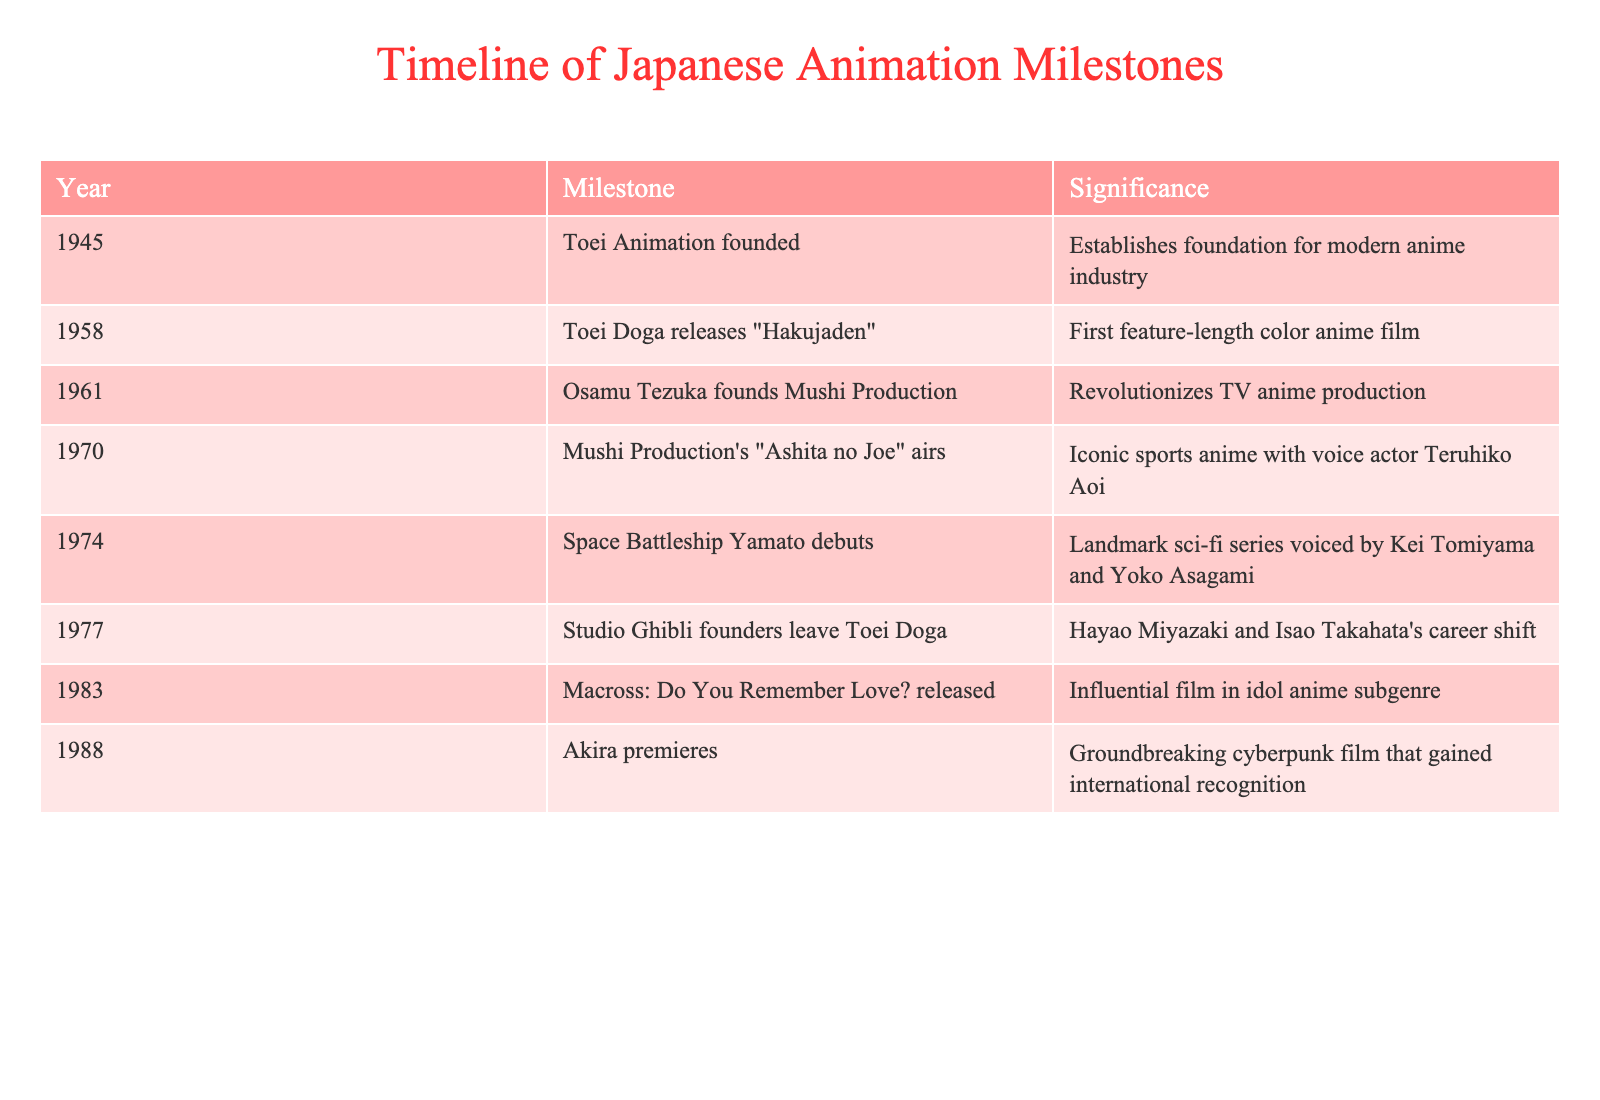What year was Toei Animation founded? The table indicates that Toei Animation was founded in the year 1945.
Answer: 1945 What milestone marked the first feature-length color anime film? According to the table, "Hakujaden" released by Toei Doga in 1958 was the first feature-length color anime film.
Answer: "Hakujaden" Which production company did Osamu Tezuka establish in 1961? The table shows that Osamu Tezuka founded Mushi Production in 1961.
Answer: Mushi Production Did "Akira" premiere before or after 1985? The table states that "Akira" premiered in 1988, which is after 1985.
Answer: After What is the significance of "Ashita no Joe"? The table notes that "Ashita no Joe" is an iconic sports anime that aired in 1970, featuring voice actor Teruhiko Aoi.
Answer: Iconic sports anime Which two notable figures left Toei Doga in 1977? The table indicates that Hayao Miyazaki and Isao Takahata are the founders who left Toei Doga in 1977.
Answer: Hayao Miyazaki and Isao Takahata How many years apart are the founding of Toei Animation and the release of "Hakujaden"? Toei Animation was founded in 1945, and "Hakujaden" was released in 1958. The difference is 1958 - 1945 = 13 years.
Answer: 13 years What significant trend can be seen between 1945 and 1988 regarding the anime industry? The table shows a progression of milestones with an increase in notable productions and innovations, suggesting a rapid growth in the anime industry from its foundation to 1988.
Answer: Rapid growth Which anime had a significant influence on the idol anime subgenre? According to the table, "Macross: Do You Remember Love?" released in 1983 had a significant influence on the idol anime subgenre.
Answer: "Macross: Do You Remember Love?" What is the first animated film listed in the table? The table indicates that the first animated film listed is "Hakujaden," released in 1958.
Answer: "Hakujaden" 